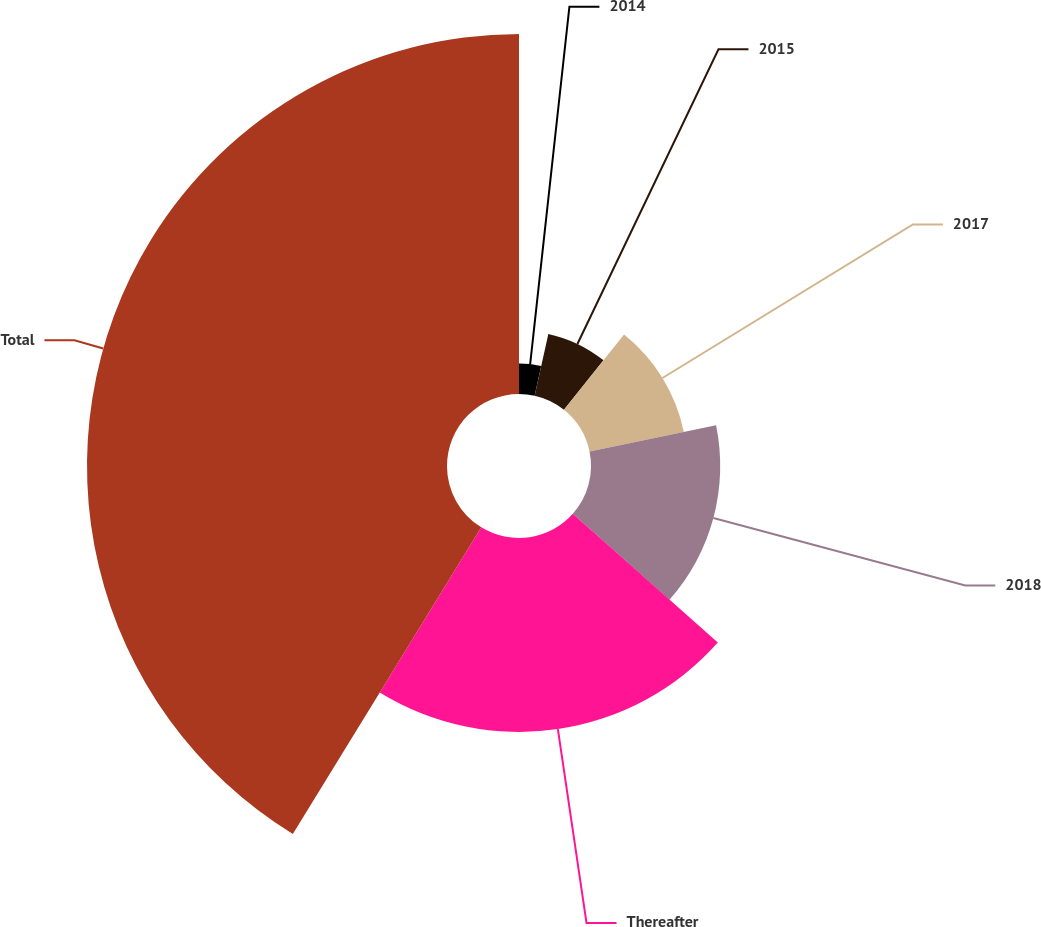<chart> <loc_0><loc_0><loc_500><loc_500><pie_chart><fcel>2014<fcel>2015<fcel>2017<fcel>2018<fcel>Thereafter<fcel>Total<nl><fcel>3.48%<fcel>7.25%<fcel>11.03%<fcel>14.8%<fcel>22.21%<fcel>41.23%<nl></chart> 